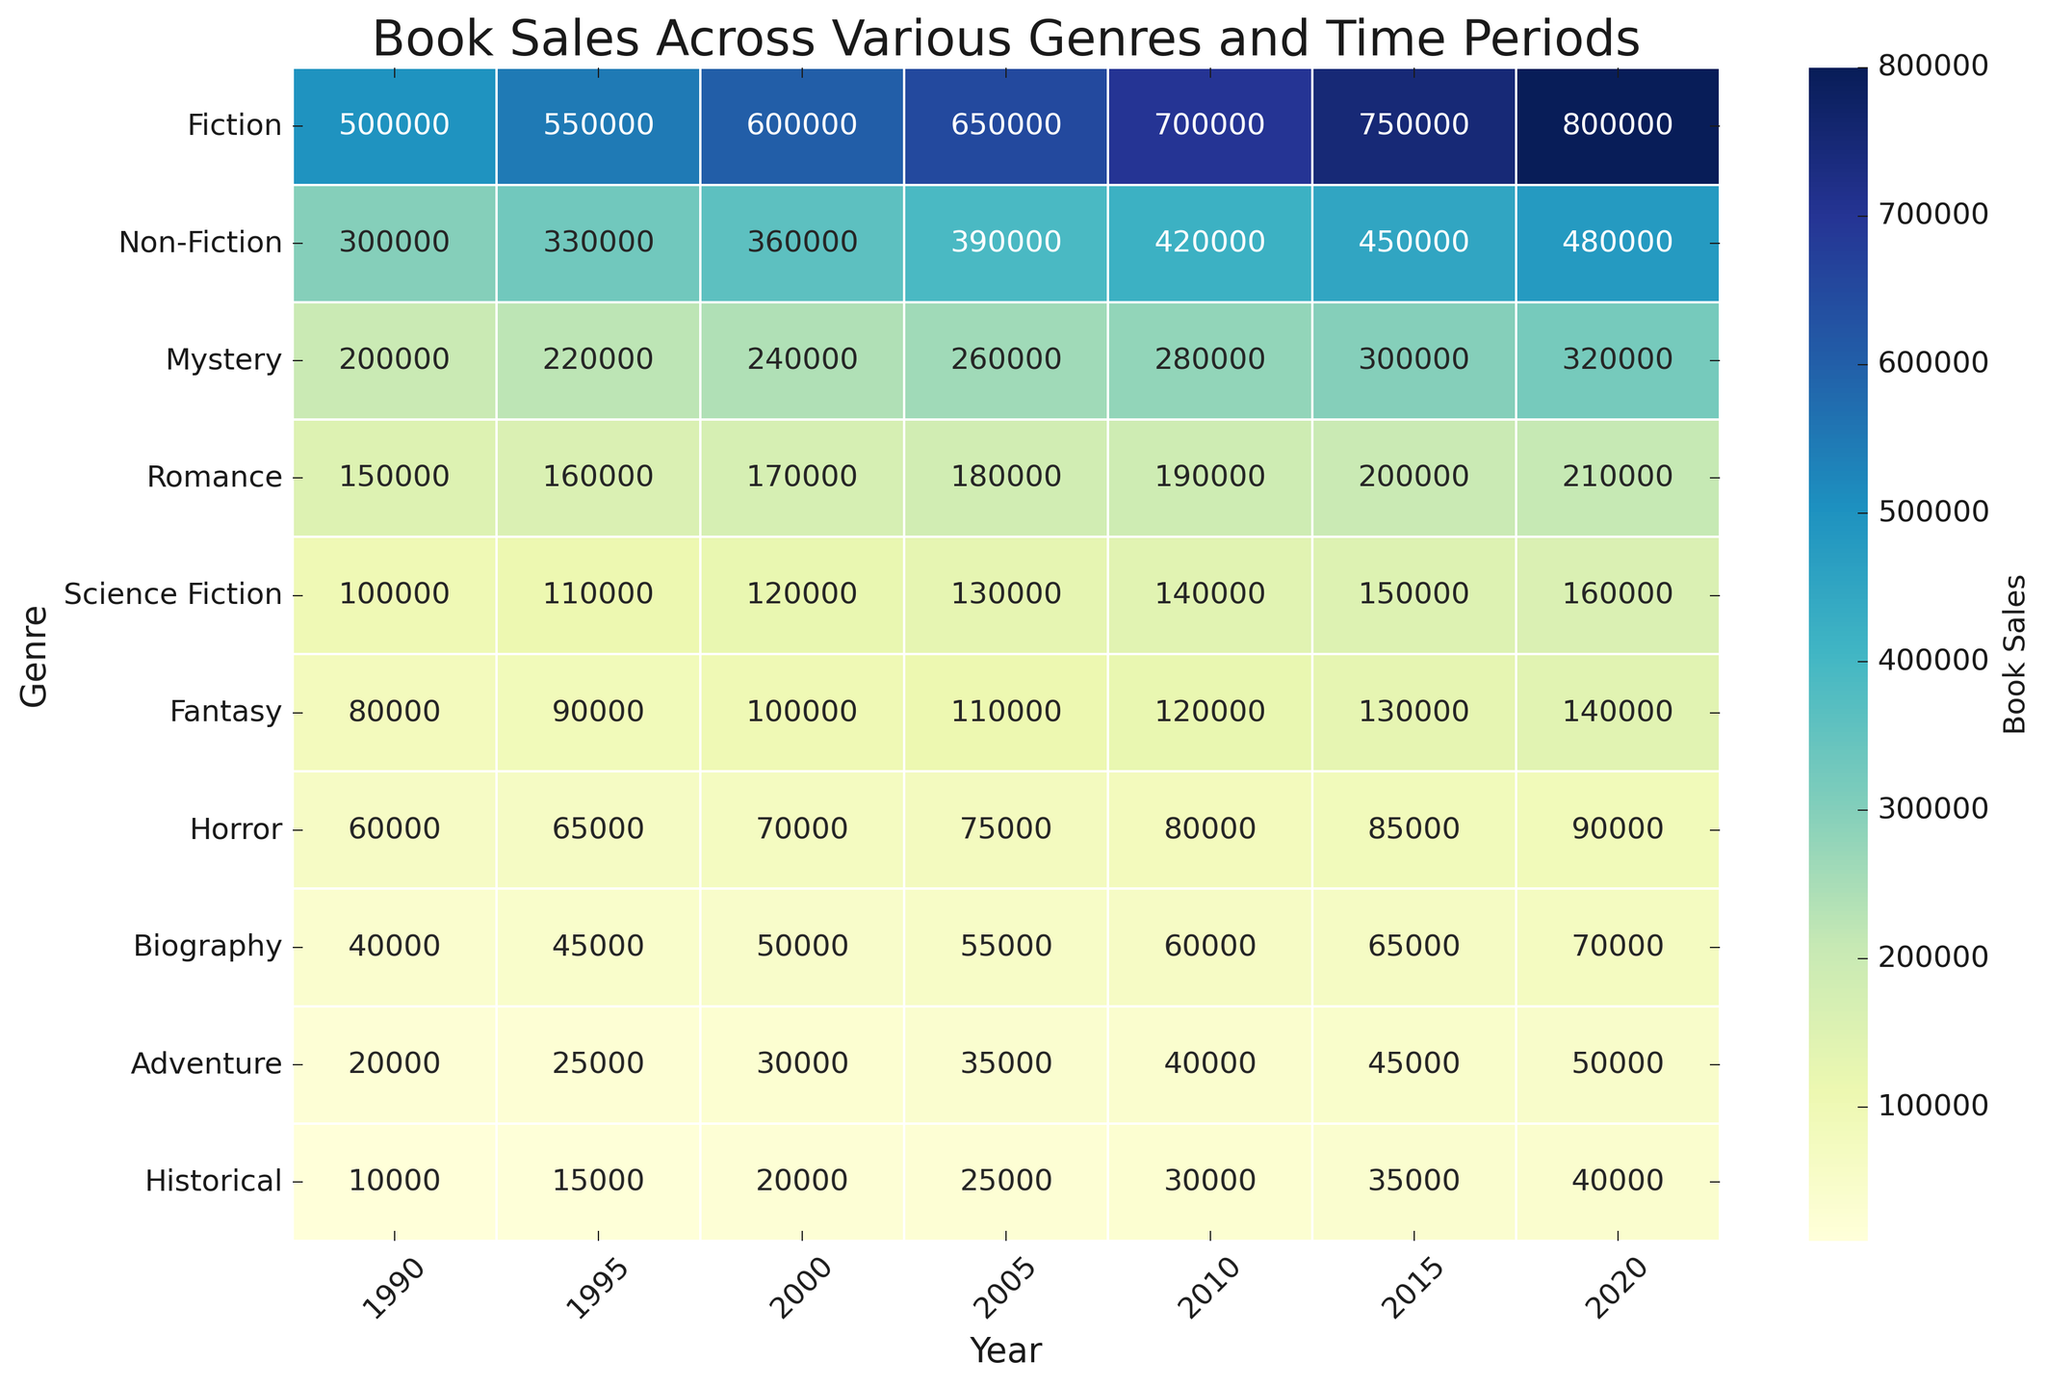What genre had the highest book sales in 1990? To determine the genre with the highest book sales in 1990, look at the leftmost column (1990) and identify the row with the highest value. Fiction sold 500,000 copies in 1990, which is the highest.
Answer: Fiction Which genre saw the most significant increase in sales between 1990 and 2020? Calculate the difference in book sales between 1990 and 2020 for each genre. The largest increase will indicate the most significant growth. Fiction increased from 500,000 to 800,000, a 300,000 increase, which is the largest.
Answer: Fiction Are sales of Fantasy books higher in 2000 or Horror books in 2010? Compare the values of Fantasy book sales in 2000 and Horror book sales in 2010. Fantasy sold 100,000 in 2000, while Horror sold 80,000 in 2010.
Answer: Fantasy in 2000 How did the sales of Non-Fiction books change between 2000 and 2015? Check the sales values of Non-Fiction books in 2000 and 2015. Non-Fiction sales were 360,000 in 2000 and 450,000 in 2015. The change is 450,000 - 360,000.
Answer: Increased by 90,000 Which year had the highest total book sales for all genres combined? Sum the sales of all genres for each year and compare the totals. Year 2020 had the highest total with Fiction (800,000) + Non-Fiction (480,000) + Mystery (320,000) + Romance (210,000) + Science Fiction (160,000) + Fantasy (140,000) + Horror (90,000) + Biography (70,000) + Adventure (50,000) + Historical (40,000) summing up to 2,360,000.
Answer: 2020 Which period sees Romance books sales reaching exactly 200,000? Look along the Romance row for a value of 200,000. This value is in the 2015 column.
Answer: 2015 Did any book genre sales decrease at any point between 1990 and 2020? Scan each row from left to right, identifying if the values ever decrease. None of the genres show a decrease; all the sales increase over time.
Answer: No Comparing Mystery and Science Fiction genres, which one had higher sales in 2005? Compare the sales values for Mystery and Science Fiction in 2005. Mystery had 260,000 sales, while Science Fiction had 130,000.
Answer: Mystery What is the average annual increase in sales for the Historical genre from 1990 to 2020? Calculate the total increase for the Historical genre from 1990 to 2020, which is 40,000 - 10,000 = 30,000. There are 30 years between 1990 and 2020, so the average annual increase is 30,000 / 30 = 1,000.
Answer: 1,000 Which two genres have the smallest difference in sales in 2015? Calculate the differences between all pairs of genres in 2015 and find the smallest one. Biography (65,000) and Historical (35,000) have the smallest difference of 30,000.
Answer: Biography and Historical 